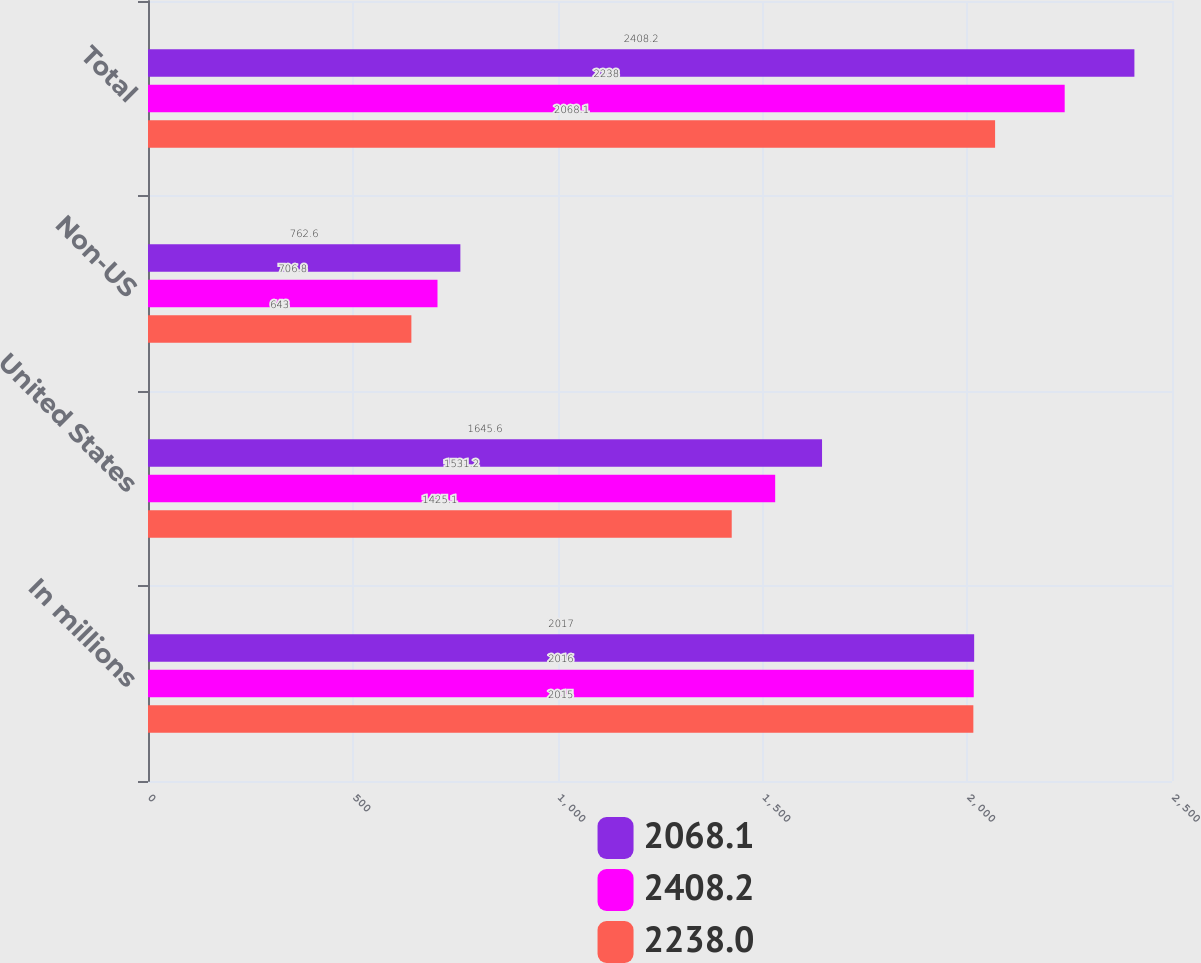<chart> <loc_0><loc_0><loc_500><loc_500><stacked_bar_chart><ecel><fcel>In millions<fcel>United States<fcel>Non-US<fcel>Total<nl><fcel>2068.1<fcel>2017<fcel>1645.6<fcel>762.6<fcel>2408.2<nl><fcel>2408.2<fcel>2016<fcel>1531.2<fcel>706.8<fcel>2238<nl><fcel>2238<fcel>2015<fcel>1425.1<fcel>643<fcel>2068.1<nl></chart> 